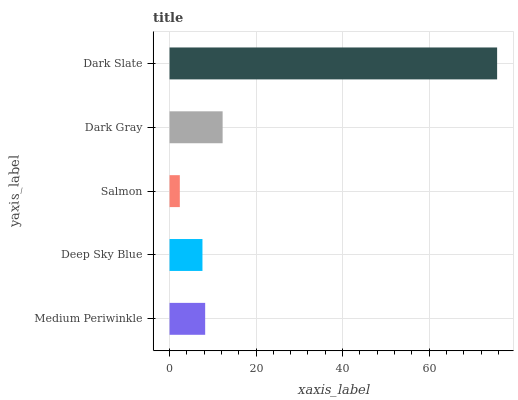Is Salmon the minimum?
Answer yes or no. Yes. Is Dark Slate the maximum?
Answer yes or no. Yes. Is Deep Sky Blue the minimum?
Answer yes or no. No. Is Deep Sky Blue the maximum?
Answer yes or no. No. Is Medium Periwinkle greater than Deep Sky Blue?
Answer yes or no. Yes. Is Deep Sky Blue less than Medium Periwinkle?
Answer yes or no. Yes. Is Deep Sky Blue greater than Medium Periwinkle?
Answer yes or no. No. Is Medium Periwinkle less than Deep Sky Blue?
Answer yes or no. No. Is Medium Periwinkle the high median?
Answer yes or no. Yes. Is Medium Periwinkle the low median?
Answer yes or no. Yes. Is Deep Sky Blue the high median?
Answer yes or no. No. Is Deep Sky Blue the low median?
Answer yes or no. No. 